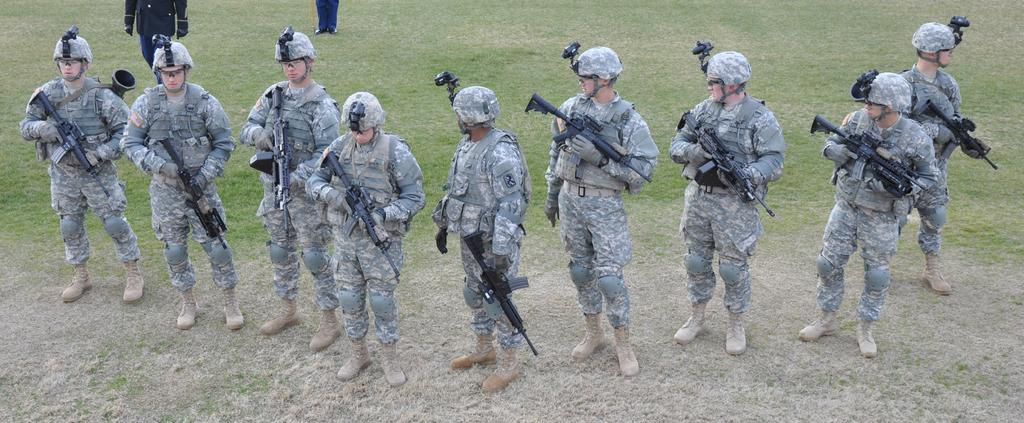What is the primary surface visible in the image? There is a ground in the image. What is happening on the ground? There are people on the ground. Can you describe the people at the top of the image? There are two persons visible at the top of the image. Reasoning: Let'g: Let's think step by step in order to produce the conversation. We start by identifying the main surface in the image, which is the ground. Then, we describe the activity taking place on the ground, which involves people. Finally, we mention the two persons visible at the top of the image, providing a sense of the overall composition. Absurd Question/Answer: What type of bear can be seen in the hospital in the image? There is no bear or hospital present in the image. 